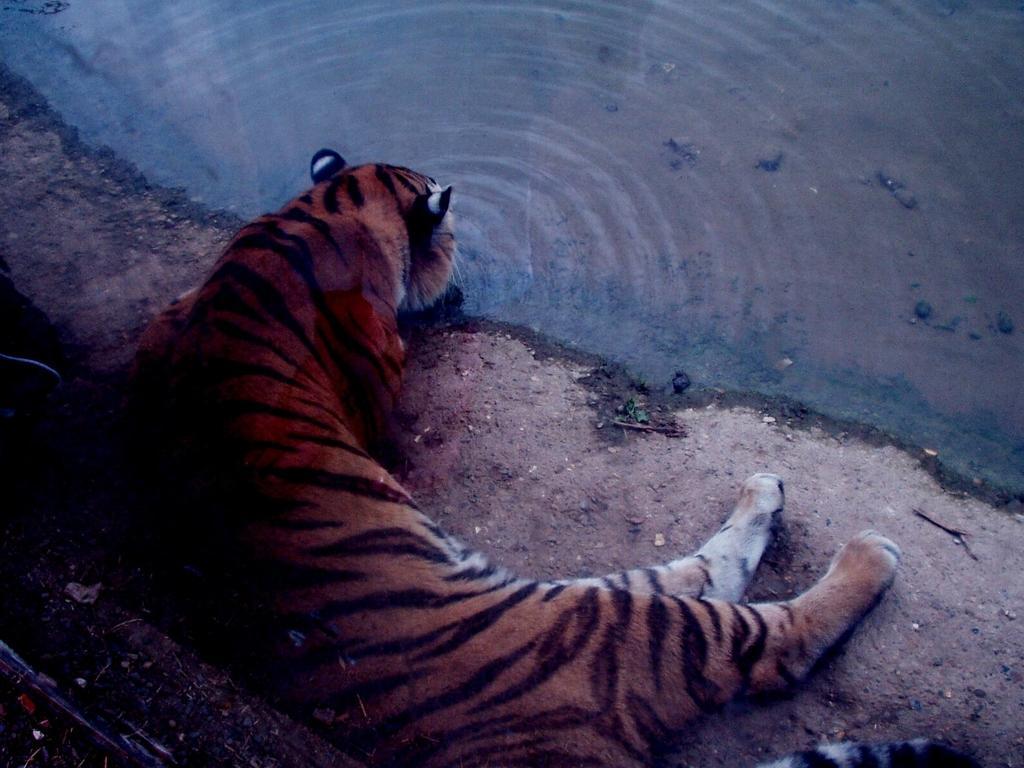Please provide a concise description of this image. This picture is clicked outside the city. In the foreground there is a tiger seems to be lying on the ground and drinking water. In the background there is a water body. 